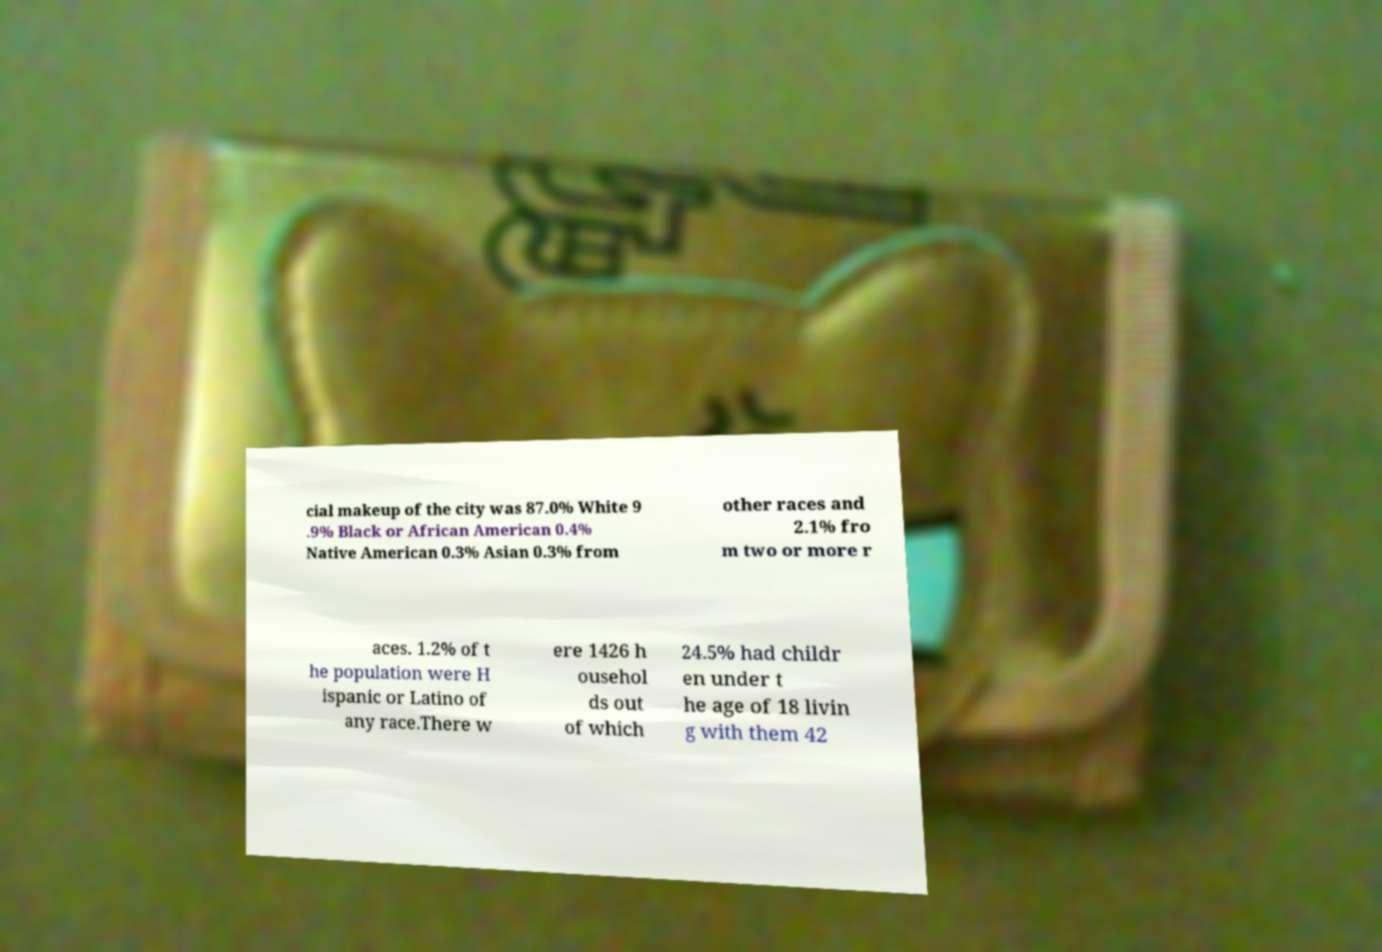Please read and relay the text visible in this image. What does it say? cial makeup of the city was 87.0% White 9 .9% Black or African American 0.4% Native American 0.3% Asian 0.3% from other races and 2.1% fro m two or more r aces. 1.2% of t he population were H ispanic or Latino of any race.There w ere 1426 h ousehol ds out of which 24.5% had childr en under t he age of 18 livin g with them 42 